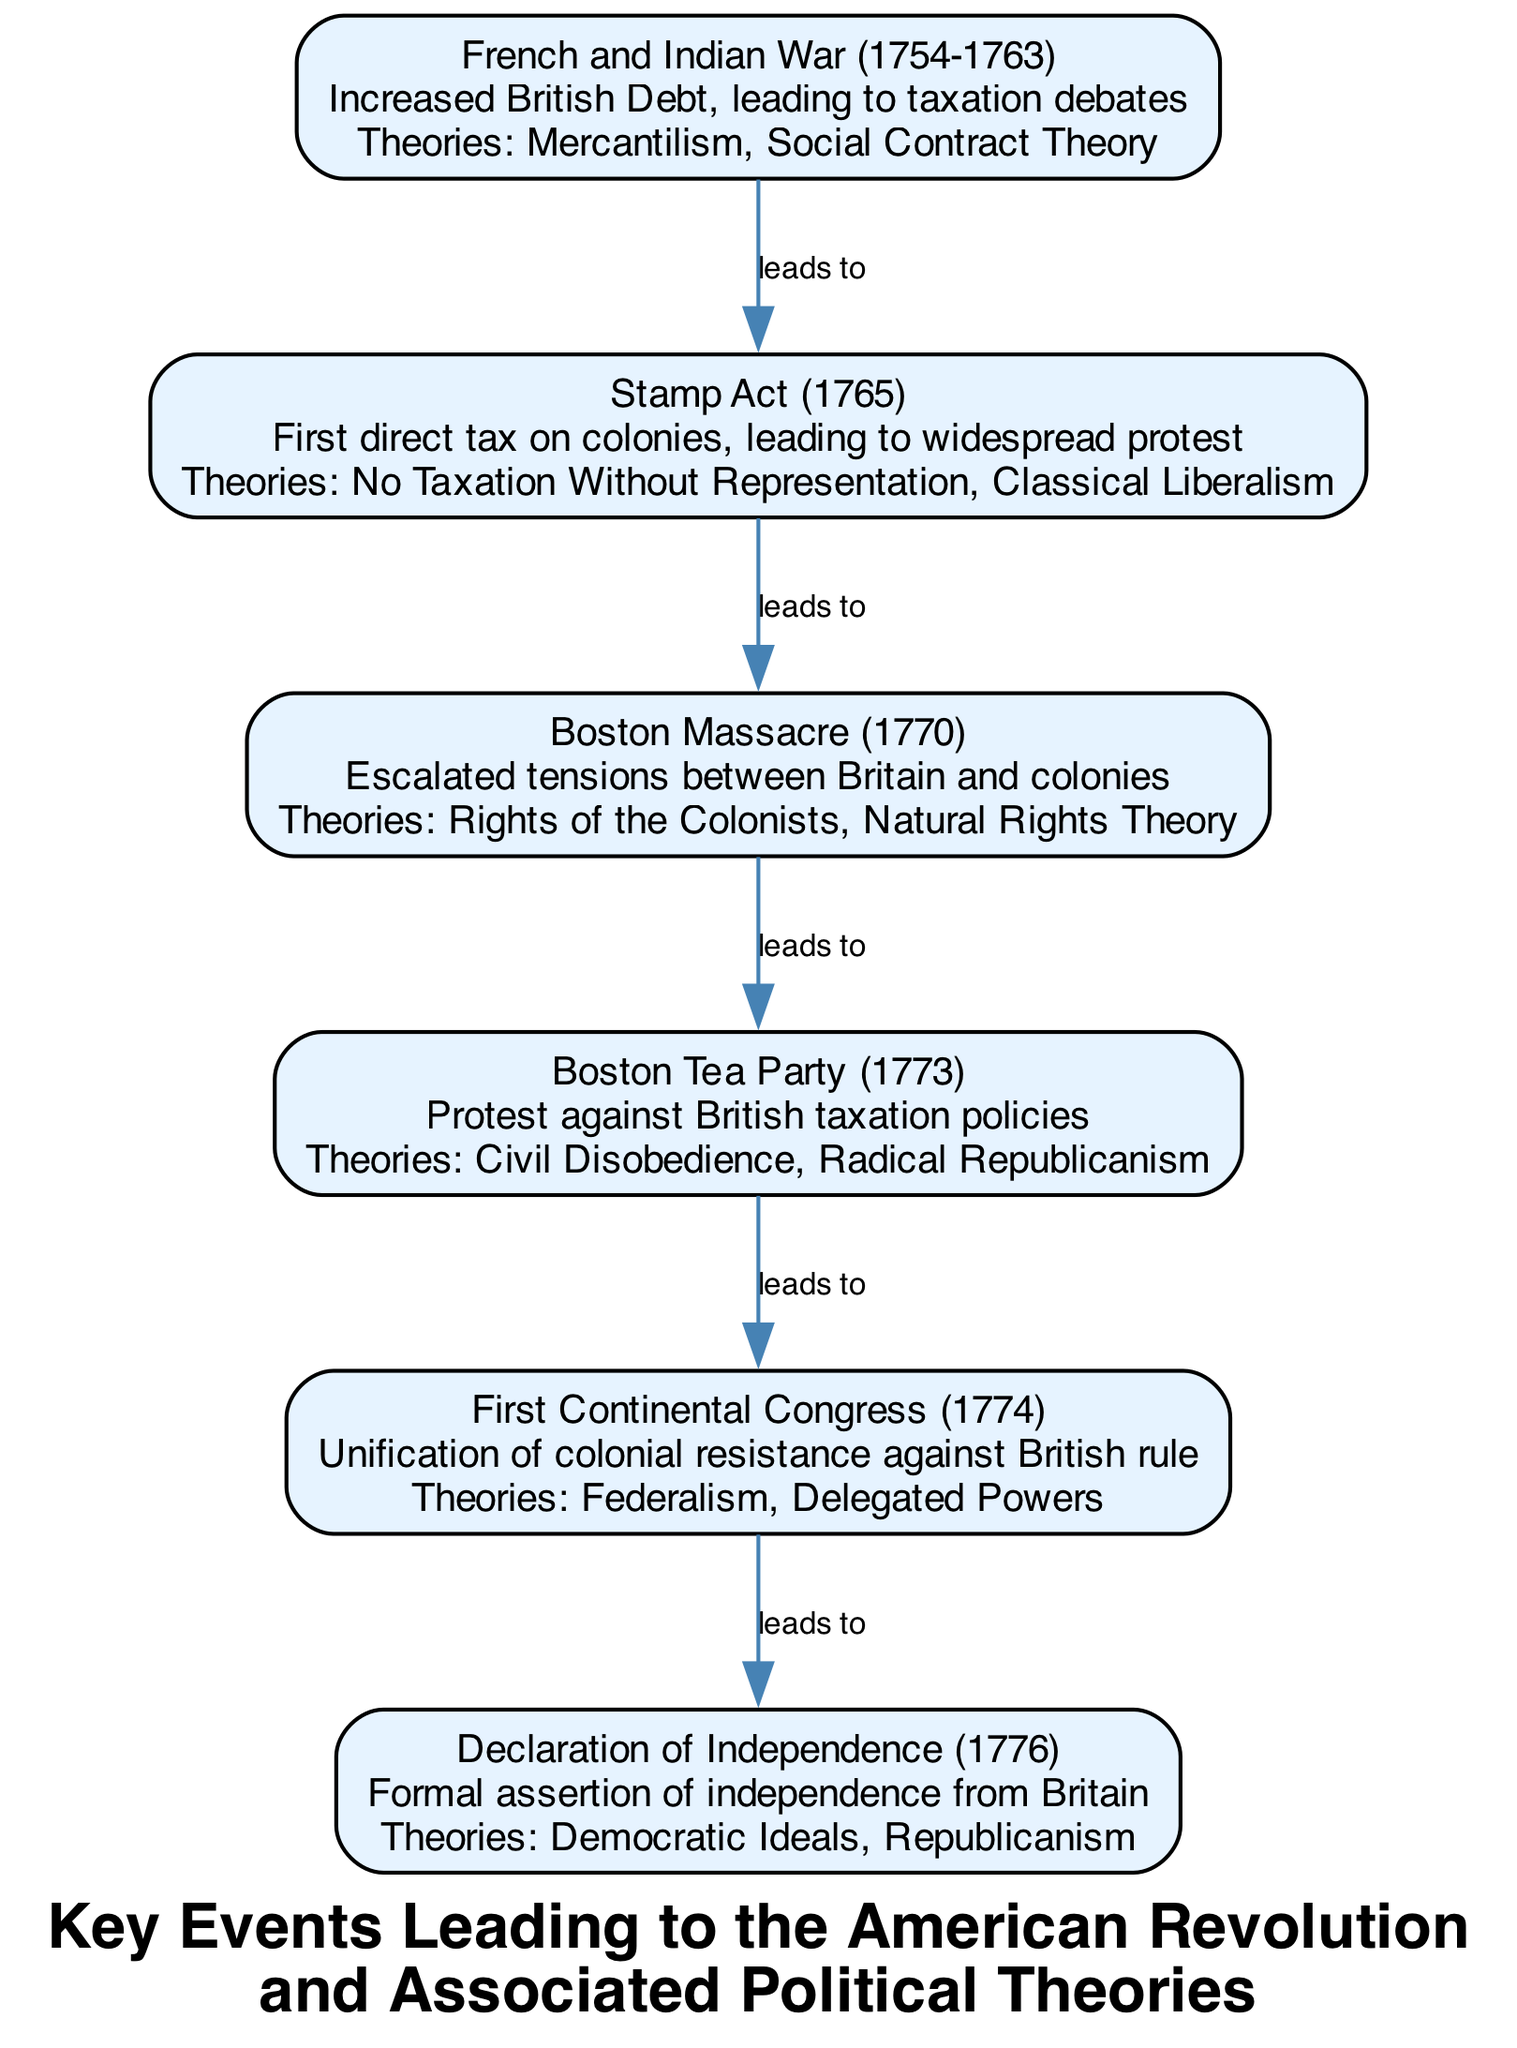What is the first event listed? The diagram presents the events in chronological order starting with the French and Indian War, which is the first event noted with details.
Answer: French and Indian War (1754-1763) What impact is associated with the Stamp Act? By examining the Stamp Act, it shows that the impact listed is "First direct tax on colonies, leading to widespread protest," as highlighted in the description of that event.
Answer: First direct tax on colonies, leading to widespread protest How many political theories are listed for the Declaration of Independence? The Declaration of Independence refers specifically to two political theories: "Democratic Ideals" and "Republicanism," which can be counted directly from that part of the diagram.
Answer: 2 What event follows the Boston Massacre? The initial events in the diagram indicate that the Boston Massacre is succeeded by the Boston Tea Party, which directly connects them in the flow of events.
Answer: Boston Tea Party (1773) Which political theory is related to civil disobedience? The Boston Tea Party is linked to the political theory of "Civil Disobedience," and this can be found specifically outlined in its section of the diagram.
Answer: Civil Disobedience What relationship is indicated between the First Continental Congress and the Declaration of Independence? The diagram sequentially connects the First Continental Congress to the Declaration of Independence, indicating that the former leads to the latter, showing a direct influence in the progression of events.
Answer: Leads to What is the impact of the Boston Tea Party? The diagram lists the impact of the Boston Tea Party as "Protest against British taxation policies," clearly shown under this event's description.
Answer: Protest against British taxation policies Which political theory is mentioned for the French and Indian War? From the section about the French and Indian War, the political theories presented are "Mercantilism" and "Social Contract Theory," both of which can be identifiably linked to this event in the diagram.
Answer: Mercantilism, Social Contract Theory How does the Boston Massacre relate to Natural Rights Theory? The Boston Massacre is shown in the diagram as having a direct connection to the political theory of Natural Rights Theory, indicating that the events of the Massacre promoted discussions and thoughts around this theory.
Answer: Rights of the Colonists, Natural Rights Theory 